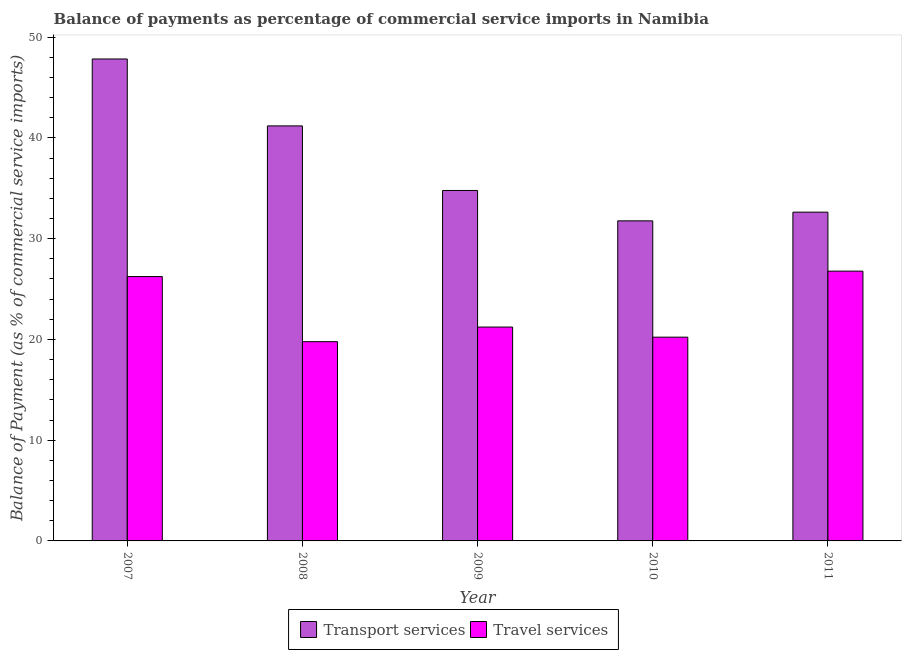How many different coloured bars are there?
Ensure brevity in your answer.  2. How many groups of bars are there?
Provide a succinct answer. 5. Are the number of bars on each tick of the X-axis equal?
Your answer should be very brief. Yes. How many bars are there on the 5th tick from the left?
Ensure brevity in your answer.  2. What is the label of the 2nd group of bars from the left?
Make the answer very short. 2008. In how many cases, is the number of bars for a given year not equal to the number of legend labels?
Your answer should be very brief. 0. What is the balance of payments of transport services in 2008?
Your response must be concise. 41.19. Across all years, what is the maximum balance of payments of transport services?
Your answer should be very brief. 47.83. Across all years, what is the minimum balance of payments of travel services?
Keep it short and to the point. 19.77. In which year was the balance of payments of travel services maximum?
Ensure brevity in your answer.  2011. What is the total balance of payments of travel services in the graph?
Your answer should be compact. 114.23. What is the difference between the balance of payments of transport services in 2007 and that in 2011?
Keep it short and to the point. 15.2. What is the difference between the balance of payments of travel services in 2011 and the balance of payments of transport services in 2009?
Give a very brief answer. 5.55. What is the average balance of payments of transport services per year?
Keep it short and to the point. 37.64. In how many years, is the balance of payments of travel services greater than 20 %?
Offer a very short reply. 4. What is the ratio of the balance of payments of transport services in 2008 to that in 2010?
Your answer should be very brief. 1.3. What is the difference between the highest and the second highest balance of payments of transport services?
Provide a short and direct response. 6.64. What is the difference between the highest and the lowest balance of payments of transport services?
Offer a terse response. 16.07. What does the 2nd bar from the left in 2007 represents?
Provide a succinct answer. Travel services. What does the 1st bar from the right in 2008 represents?
Your response must be concise. Travel services. How many bars are there?
Provide a short and direct response. 10. How many years are there in the graph?
Offer a very short reply. 5. What is the difference between two consecutive major ticks on the Y-axis?
Your answer should be very brief. 10. Does the graph contain any zero values?
Keep it short and to the point. No. Does the graph contain grids?
Your answer should be compact. No. How many legend labels are there?
Give a very brief answer. 2. How are the legend labels stacked?
Your response must be concise. Horizontal. What is the title of the graph?
Your answer should be very brief. Balance of payments as percentage of commercial service imports in Namibia. Does "From World Bank" appear as one of the legend labels in the graph?
Offer a very short reply. No. What is the label or title of the Y-axis?
Your answer should be very brief. Balance of Payment (as % of commercial service imports). What is the Balance of Payment (as % of commercial service imports) of Transport services in 2007?
Ensure brevity in your answer.  47.83. What is the Balance of Payment (as % of commercial service imports) in Travel services in 2007?
Your answer should be compact. 26.24. What is the Balance of Payment (as % of commercial service imports) in Transport services in 2008?
Your answer should be compact. 41.19. What is the Balance of Payment (as % of commercial service imports) in Travel services in 2008?
Make the answer very short. 19.77. What is the Balance of Payment (as % of commercial service imports) in Transport services in 2009?
Your answer should be compact. 34.78. What is the Balance of Payment (as % of commercial service imports) in Travel services in 2009?
Your answer should be compact. 21.22. What is the Balance of Payment (as % of commercial service imports) of Transport services in 2010?
Keep it short and to the point. 31.77. What is the Balance of Payment (as % of commercial service imports) of Travel services in 2010?
Offer a terse response. 20.22. What is the Balance of Payment (as % of commercial service imports) of Transport services in 2011?
Offer a terse response. 32.63. What is the Balance of Payment (as % of commercial service imports) in Travel services in 2011?
Your response must be concise. 26.77. Across all years, what is the maximum Balance of Payment (as % of commercial service imports) in Transport services?
Ensure brevity in your answer.  47.83. Across all years, what is the maximum Balance of Payment (as % of commercial service imports) in Travel services?
Your response must be concise. 26.77. Across all years, what is the minimum Balance of Payment (as % of commercial service imports) of Transport services?
Make the answer very short. 31.77. Across all years, what is the minimum Balance of Payment (as % of commercial service imports) of Travel services?
Your answer should be compact. 19.77. What is the total Balance of Payment (as % of commercial service imports) in Transport services in the graph?
Give a very brief answer. 188.19. What is the total Balance of Payment (as % of commercial service imports) of Travel services in the graph?
Provide a succinct answer. 114.23. What is the difference between the Balance of Payment (as % of commercial service imports) of Transport services in 2007 and that in 2008?
Ensure brevity in your answer.  6.64. What is the difference between the Balance of Payment (as % of commercial service imports) of Travel services in 2007 and that in 2008?
Your response must be concise. 6.46. What is the difference between the Balance of Payment (as % of commercial service imports) of Transport services in 2007 and that in 2009?
Make the answer very short. 13.05. What is the difference between the Balance of Payment (as % of commercial service imports) of Travel services in 2007 and that in 2009?
Make the answer very short. 5.01. What is the difference between the Balance of Payment (as % of commercial service imports) in Transport services in 2007 and that in 2010?
Your response must be concise. 16.07. What is the difference between the Balance of Payment (as % of commercial service imports) of Travel services in 2007 and that in 2010?
Provide a succinct answer. 6.01. What is the difference between the Balance of Payment (as % of commercial service imports) of Transport services in 2007 and that in 2011?
Provide a short and direct response. 15.2. What is the difference between the Balance of Payment (as % of commercial service imports) in Travel services in 2007 and that in 2011?
Your response must be concise. -0.54. What is the difference between the Balance of Payment (as % of commercial service imports) in Transport services in 2008 and that in 2009?
Offer a very short reply. 6.41. What is the difference between the Balance of Payment (as % of commercial service imports) in Travel services in 2008 and that in 2009?
Your answer should be very brief. -1.45. What is the difference between the Balance of Payment (as % of commercial service imports) in Transport services in 2008 and that in 2010?
Keep it short and to the point. 9.42. What is the difference between the Balance of Payment (as % of commercial service imports) in Travel services in 2008 and that in 2010?
Your response must be concise. -0.45. What is the difference between the Balance of Payment (as % of commercial service imports) of Transport services in 2008 and that in 2011?
Your response must be concise. 8.56. What is the difference between the Balance of Payment (as % of commercial service imports) in Travel services in 2008 and that in 2011?
Offer a very short reply. -7. What is the difference between the Balance of Payment (as % of commercial service imports) of Transport services in 2009 and that in 2010?
Your response must be concise. 3.01. What is the difference between the Balance of Payment (as % of commercial service imports) of Transport services in 2009 and that in 2011?
Offer a terse response. 2.15. What is the difference between the Balance of Payment (as % of commercial service imports) of Travel services in 2009 and that in 2011?
Give a very brief answer. -5.55. What is the difference between the Balance of Payment (as % of commercial service imports) of Transport services in 2010 and that in 2011?
Make the answer very short. -0.86. What is the difference between the Balance of Payment (as % of commercial service imports) in Travel services in 2010 and that in 2011?
Offer a very short reply. -6.55. What is the difference between the Balance of Payment (as % of commercial service imports) in Transport services in 2007 and the Balance of Payment (as % of commercial service imports) in Travel services in 2008?
Give a very brief answer. 28.06. What is the difference between the Balance of Payment (as % of commercial service imports) in Transport services in 2007 and the Balance of Payment (as % of commercial service imports) in Travel services in 2009?
Your response must be concise. 26.61. What is the difference between the Balance of Payment (as % of commercial service imports) in Transport services in 2007 and the Balance of Payment (as % of commercial service imports) in Travel services in 2010?
Give a very brief answer. 27.61. What is the difference between the Balance of Payment (as % of commercial service imports) of Transport services in 2007 and the Balance of Payment (as % of commercial service imports) of Travel services in 2011?
Your response must be concise. 21.06. What is the difference between the Balance of Payment (as % of commercial service imports) of Transport services in 2008 and the Balance of Payment (as % of commercial service imports) of Travel services in 2009?
Provide a short and direct response. 19.96. What is the difference between the Balance of Payment (as % of commercial service imports) of Transport services in 2008 and the Balance of Payment (as % of commercial service imports) of Travel services in 2010?
Your answer should be very brief. 20.97. What is the difference between the Balance of Payment (as % of commercial service imports) in Transport services in 2008 and the Balance of Payment (as % of commercial service imports) in Travel services in 2011?
Offer a terse response. 14.41. What is the difference between the Balance of Payment (as % of commercial service imports) in Transport services in 2009 and the Balance of Payment (as % of commercial service imports) in Travel services in 2010?
Offer a terse response. 14.56. What is the difference between the Balance of Payment (as % of commercial service imports) in Transport services in 2009 and the Balance of Payment (as % of commercial service imports) in Travel services in 2011?
Offer a very short reply. 8.01. What is the difference between the Balance of Payment (as % of commercial service imports) of Transport services in 2010 and the Balance of Payment (as % of commercial service imports) of Travel services in 2011?
Your answer should be very brief. 4.99. What is the average Balance of Payment (as % of commercial service imports) of Transport services per year?
Keep it short and to the point. 37.64. What is the average Balance of Payment (as % of commercial service imports) of Travel services per year?
Your answer should be very brief. 22.85. In the year 2007, what is the difference between the Balance of Payment (as % of commercial service imports) in Transport services and Balance of Payment (as % of commercial service imports) in Travel services?
Make the answer very short. 21.59. In the year 2008, what is the difference between the Balance of Payment (as % of commercial service imports) of Transport services and Balance of Payment (as % of commercial service imports) of Travel services?
Your response must be concise. 21.41. In the year 2009, what is the difference between the Balance of Payment (as % of commercial service imports) of Transport services and Balance of Payment (as % of commercial service imports) of Travel services?
Give a very brief answer. 13.55. In the year 2010, what is the difference between the Balance of Payment (as % of commercial service imports) in Transport services and Balance of Payment (as % of commercial service imports) in Travel services?
Offer a terse response. 11.54. In the year 2011, what is the difference between the Balance of Payment (as % of commercial service imports) of Transport services and Balance of Payment (as % of commercial service imports) of Travel services?
Your answer should be very brief. 5.85. What is the ratio of the Balance of Payment (as % of commercial service imports) in Transport services in 2007 to that in 2008?
Your answer should be very brief. 1.16. What is the ratio of the Balance of Payment (as % of commercial service imports) in Travel services in 2007 to that in 2008?
Your response must be concise. 1.33. What is the ratio of the Balance of Payment (as % of commercial service imports) in Transport services in 2007 to that in 2009?
Give a very brief answer. 1.38. What is the ratio of the Balance of Payment (as % of commercial service imports) in Travel services in 2007 to that in 2009?
Offer a very short reply. 1.24. What is the ratio of the Balance of Payment (as % of commercial service imports) of Transport services in 2007 to that in 2010?
Your answer should be very brief. 1.51. What is the ratio of the Balance of Payment (as % of commercial service imports) of Travel services in 2007 to that in 2010?
Your response must be concise. 1.3. What is the ratio of the Balance of Payment (as % of commercial service imports) in Transport services in 2007 to that in 2011?
Provide a succinct answer. 1.47. What is the ratio of the Balance of Payment (as % of commercial service imports) in Travel services in 2007 to that in 2011?
Offer a very short reply. 0.98. What is the ratio of the Balance of Payment (as % of commercial service imports) of Transport services in 2008 to that in 2009?
Your answer should be very brief. 1.18. What is the ratio of the Balance of Payment (as % of commercial service imports) in Travel services in 2008 to that in 2009?
Offer a terse response. 0.93. What is the ratio of the Balance of Payment (as % of commercial service imports) of Transport services in 2008 to that in 2010?
Provide a succinct answer. 1.3. What is the ratio of the Balance of Payment (as % of commercial service imports) in Travel services in 2008 to that in 2010?
Keep it short and to the point. 0.98. What is the ratio of the Balance of Payment (as % of commercial service imports) of Transport services in 2008 to that in 2011?
Provide a short and direct response. 1.26. What is the ratio of the Balance of Payment (as % of commercial service imports) of Travel services in 2008 to that in 2011?
Give a very brief answer. 0.74. What is the ratio of the Balance of Payment (as % of commercial service imports) in Transport services in 2009 to that in 2010?
Make the answer very short. 1.09. What is the ratio of the Balance of Payment (as % of commercial service imports) of Travel services in 2009 to that in 2010?
Keep it short and to the point. 1.05. What is the ratio of the Balance of Payment (as % of commercial service imports) in Transport services in 2009 to that in 2011?
Your response must be concise. 1.07. What is the ratio of the Balance of Payment (as % of commercial service imports) of Travel services in 2009 to that in 2011?
Your response must be concise. 0.79. What is the ratio of the Balance of Payment (as % of commercial service imports) of Transport services in 2010 to that in 2011?
Offer a terse response. 0.97. What is the ratio of the Balance of Payment (as % of commercial service imports) of Travel services in 2010 to that in 2011?
Offer a very short reply. 0.76. What is the difference between the highest and the second highest Balance of Payment (as % of commercial service imports) of Transport services?
Your answer should be compact. 6.64. What is the difference between the highest and the second highest Balance of Payment (as % of commercial service imports) in Travel services?
Make the answer very short. 0.54. What is the difference between the highest and the lowest Balance of Payment (as % of commercial service imports) in Transport services?
Ensure brevity in your answer.  16.07. What is the difference between the highest and the lowest Balance of Payment (as % of commercial service imports) in Travel services?
Provide a succinct answer. 7. 